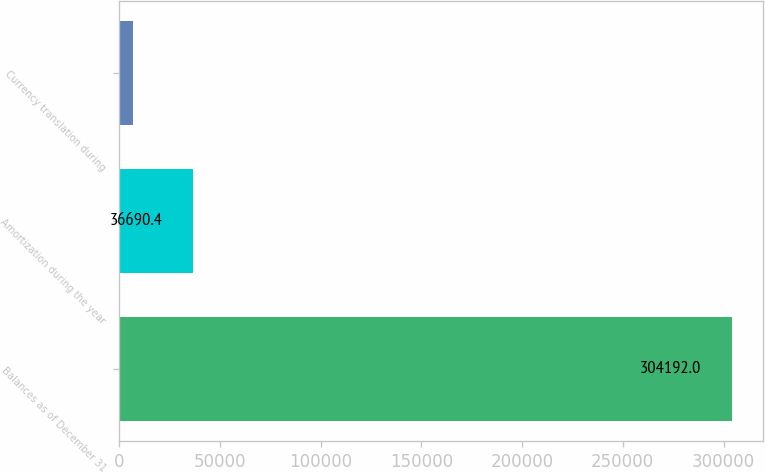<chart> <loc_0><loc_0><loc_500><loc_500><bar_chart><fcel>Balances as of December 31<fcel>Amortization during the year<fcel>Currency translation during<nl><fcel>304192<fcel>36690.4<fcel>6968<nl></chart> 